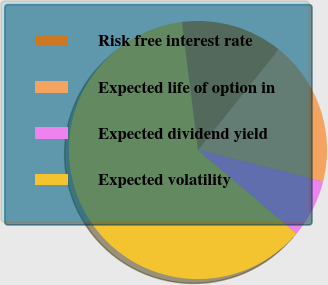<chart> <loc_0><loc_0><loc_500><loc_500><pie_chart><fcel>Risk free interest rate<fcel>Expected life of option in<fcel>Expected dividend yield<fcel>Expected volatility<nl><fcel>12.73%<fcel>18.19%<fcel>7.28%<fcel>61.8%<nl></chart> 